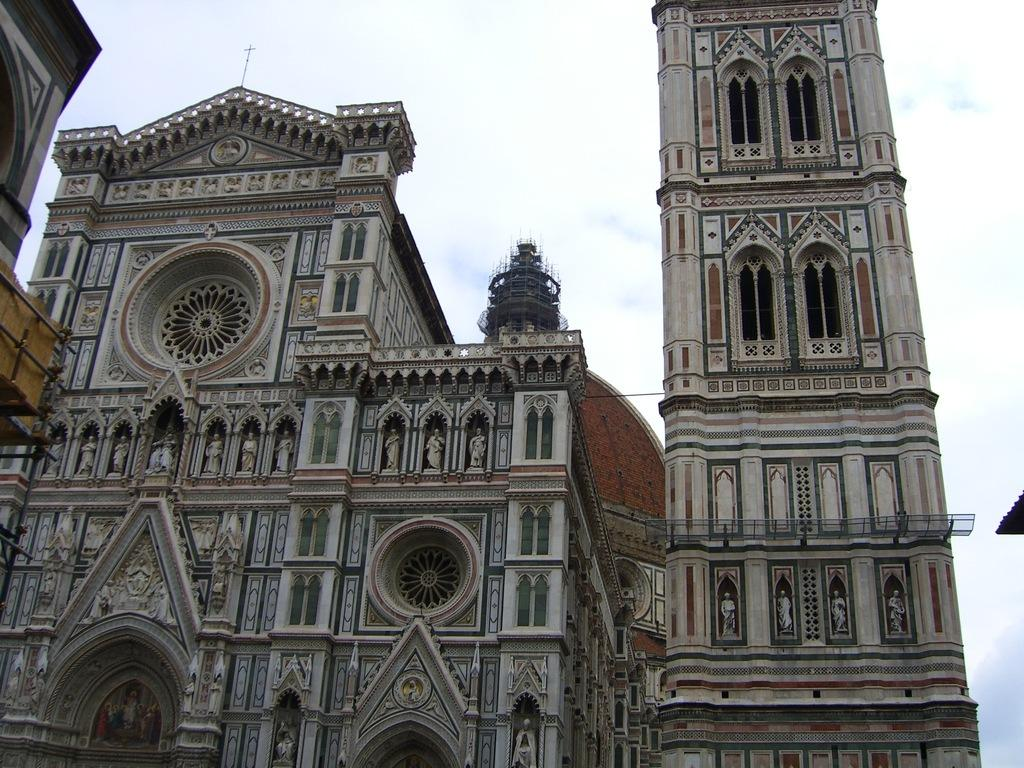What is the main subject in the center of the image? There are buildings in the center of the image. What can be seen in the background of the image? The sky is visible in the background of the image. What type of game is being played in the image? There is no game present in the image; it features buildings and the sky. Is there any popcorn visible in the image? There is no popcorn present in the image. 